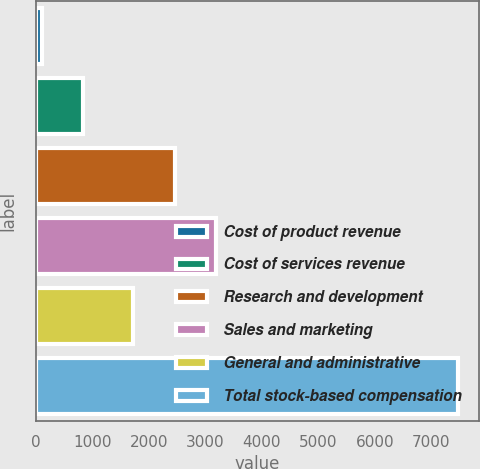Convert chart to OTSL. <chart><loc_0><loc_0><loc_500><loc_500><bar_chart><fcel>Cost of product revenue<fcel>Cost of services revenue<fcel>Research and development<fcel>Sales and marketing<fcel>General and administrative<fcel>Total stock-based compensation<nl><fcel>102<fcel>837.9<fcel>2453.9<fcel>3189.8<fcel>1718<fcel>7461<nl></chart> 